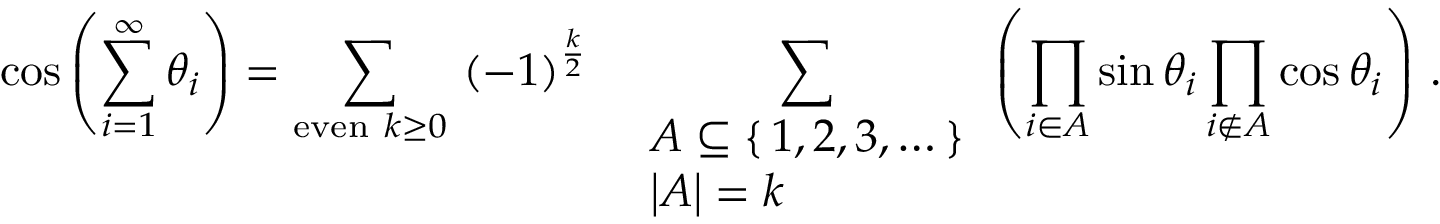Convert formula to latex. <formula><loc_0><loc_0><loc_500><loc_500>\cos \left ( \sum _ { i = 1 } ^ { \infty } \theta _ { i } \right ) = \sum _ { { e v e n } \ k \geq 0 } ( - 1 ) ^ { \frac { k } { 2 } } \sum _ { \begin{array} { l } { A \subseteq \{ \, 1 , 2 , 3 , \dots \, \} } \\ { \left | A \right | = k } \end{array} } \left ( \prod _ { i \in A } \sin \theta _ { i } \prod _ { i \not \in A } \cos \theta _ { i } \right ) \, .</formula> 